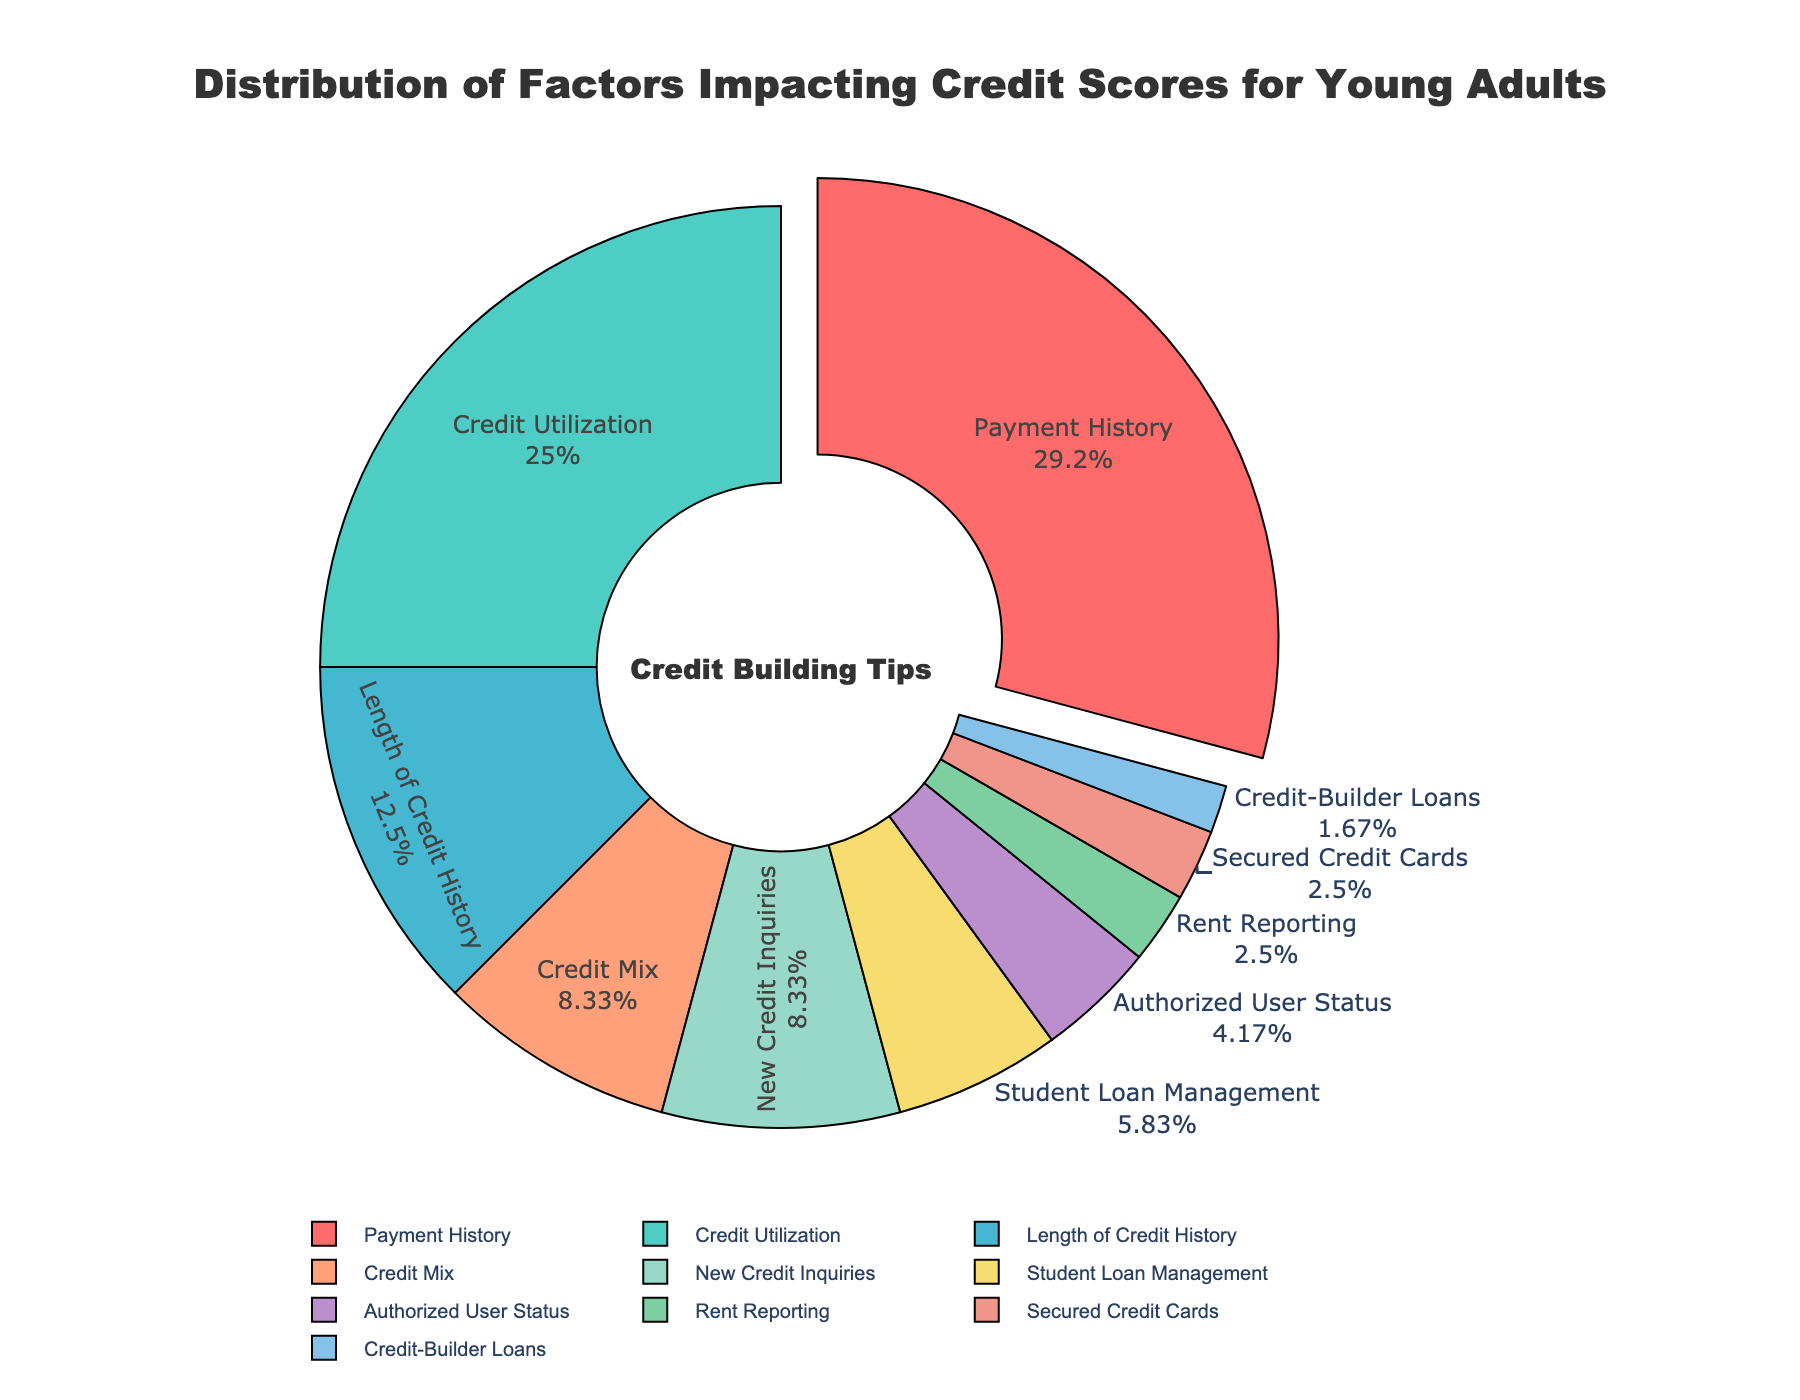what is the largest factor impacting credit scores for young adults? The largest factor can be found by looking at the category with the highest percentage. The payment history has the largest slice marked with 35%.
Answer: Payment History Which two categories together account for half of the pie chart? To find two categories accounting for half of 100%, we need to find categories together forming 50%. Payment History (35%) plus Credit Utilization (30%) equals 65%, which exceeds 50%. Next largest, Payment History (35%) and Length of Credit History (15%) sum to 50%.
Answer: Payment History and Credit Utilization What is the difference in percentage between Credit Utilization and Length of Credit History? The difference is calculated by subtracting the smaller percentage from the larger one. Credit Utilization is 30%, and Length of Credit History is 15%. So, 30% - 15% = 15%.
Answer: 15% Which categories impact credit scores less than 5%? Categories with percentages less than 5% are identified by their slice sizes which are noticeably smaller. Authorized User Status (5%), Rent Reporting (3%), Secured Credit Cards (3%), Credit-Builder Loans (2%) are these categories.
Answer: Authorized User Status, Rent Reporting, Secured Credit Cards, Credit-Builder Loans Among the smaller impact factors, which one has a 3% contribution to the credit score? To find factors contributing 3%, look at wedges with labels showing 3%. Rent Reporting and Secured Credit Cards each contribute 3%.
Answer: Rent Reporting, Secured Credit Cards Which has a higher percentage: New Credit Inquiries or Student Loan Management? Comparing these two categories, New Credit Inquiries is 10%, whereas Student Loan Management is 7%. Since 10% > 7%, New Credit Inquiries is higher.
Answer: New Credit Inquiries What is the sum percentage of the three least impacting categories on credit scores? Identify the three smallest percentages: Rent Reporting (3%), Secured Credit Cards (3%), and Credit-Builder Loans (2%). Summing these gives 3% + 3% + 2% = 8%.
Answer: 8% How much higher is Payment History's impact compared to Authorized User Status? Payment History is 35%, while Authorized User Status is 5%. The difference is 35% - 5% = 30%.
Answer: 30% What percentage do Credit Mix and New Credit Inquiries account for together? Add the percentages of Credit Mix and New Credit Inquiries. Credit Mix is 10%, New Credit Inquiries is 10%. Therefore, 10% + 10% = 20%.
Answer: 20% 